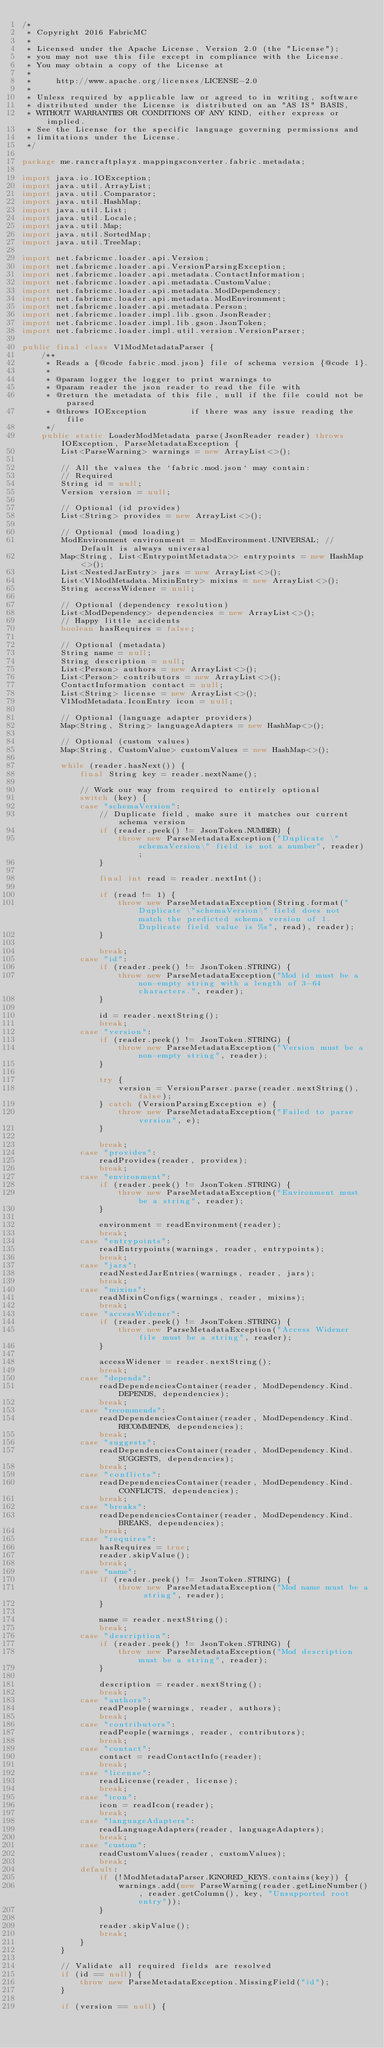Convert code to text. <code><loc_0><loc_0><loc_500><loc_500><_Java_>/*
 * Copyright 2016 FabricMC
 *
 * Licensed under the Apache License, Version 2.0 (the "License");
 * you may not use this file except in compliance with the License.
 * You may obtain a copy of the License at
 *
 *     http://www.apache.org/licenses/LICENSE-2.0
 *
 * Unless required by applicable law or agreed to in writing, software
 * distributed under the License is distributed on an "AS IS" BASIS,
 * WITHOUT WARRANTIES OR CONDITIONS OF ANY KIND, either express or implied.
 * See the License for the specific language governing permissions and
 * limitations under the License.
 */

package me.rancraftplayz.mappingsconverter.fabric.metadata;

import java.io.IOException;
import java.util.ArrayList;
import java.util.Comparator;
import java.util.HashMap;
import java.util.List;
import java.util.Locale;
import java.util.Map;
import java.util.SortedMap;
import java.util.TreeMap;

import net.fabricmc.loader.api.Version;
import net.fabricmc.loader.api.VersionParsingException;
import net.fabricmc.loader.api.metadata.ContactInformation;
import net.fabricmc.loader.api.metadata.CustomValue;
import net.fabricmc.loader.api.metadata.ModDependency;
import net.fabricmc.loader.api.metadata.ModEnvironment;
import net.fabricmc.loader.api.metadata.Person;
import net.fabricmc.loader.impl.lib.gson.JsonReader;
import net.fabricmc.loader.impl.lib.gson.JsonToken;
import net.fabricmc.loader.impl.util.version.VersionParser;

public final class V1ModMetadataParser {
	/**
	 * Reads a {@code fabric.mod.json} file of schema version {@code 1}.
	 *
	 * @param logger the logger to print warnings to
	 * @param reader the json reader to read the file with
	 * @return the metadata of this file, null if the file could not be parsed
	 * @throws IOException         if there was any issue reading the file
	 */
	public static LoaderModMetadata parse(JsonReader reader) throws IOException, ParseMetadataException {
		List<ParseWarning> warnings = new ArrayList<>();

		// All the values the `fabric.mod.json` may contain:
		// Required
		String id = null;
		Version version = null;

		// Optional (id provides)
		List<String> provides = new ArrayList<>();

		// Optional (mod loading)
		ModEnvironment environment = ModEnvironment.UNIVERSAL; // Default is always universal
		Map<String, List<EntrypointMetadata>> entrypoints = new HashMap<>();
		List<NestedJarEntry> jars = new ArrayList<>();
		List<V1ModMetadata.MixinEntry> mixins = new ArrayList<>();
		String accessWidener = null;

		// Optional (dependency resolution)
		List<ModDependency> dependencies = new ArrayList<>();
		// Happy little accidents
		boolean hasRequires = false;

		// Optional (metadata)
		String name = null;
		String description = null;
		List<Person> authors = new ArrayList<>();
		List<Person> contributors = new ArrayList<>();
		ContactInformation contact = null;
		List<String> license = new ArrayList<>();
		V1ModMetadata.IconEntry icon = null;

		// Optional (language adapter providers)
		Map<String, String> languageAdapters = new HashMap<>();

		// Optional (custom values)
		Map<String, CustomValue> customValues = new HashMap<>();

		while (reader.hasNext()) {
			final String key = reader.nextName();

			// Work our way from required to entirely optional
			switch (key) {
			case "schemaVersion":
				// Duplicate field, make sure it matches our current schema version
				if (reader.peek() != JsonToken.NUMBER) {
					throw new ParseMetadataException("Duplicate \"schemaVersion\" field is not a number", reader);
				}

				final int read = reader.nextInt();

				if (read != 1) {
					throw new ParseMetadataException(String.format("Duplicate \"schemaVersion\" field does not match the predicted schema version of 1. Duplicate field value is %s", read), reader);
				}

				break;
			case "id":
				if (reader.peek() != JsonToken.STRING) {
					throw new ParseMetadataException("Mod id must be a non-empty string with a length of 3-64 characters.", reader);
				}

				id = reader.nextString();
				break;
			case "version":
				if (reader.peek() != JsonToken.STRING) {
					throw new ParseMetadataException("Version must be a non-empty string", reader);
				}

				try {
					version = VersionParser.parse(reader.nextString(), false);
				} catch (VersionParsingException e) {
					throw new ParseMetadataException("Failed to parse version", e);
				}

				break;
			case "provides":
				readProvides(reader, provides);
				break;
			case "environment":
				if (reader.peek() != JsonToken.STRING) {
					throw new ParseMetadataException("Environment must be a string", reader);
				}

				environment = readEnvironment(reader);
				break;
			case "entrypoints":
				readEntrypoints(warnings, reader, entrypoints);
				break;
			case "jars":
				readNestedJarEntries(warnings, reader, jars);
				break;
			case "mixins":
				readMixinConfigs(warnings, reader, mixins);
				break;
			case "accessWidener":
				if (reader.peek() != JsonToken.STRING) {
					throw new ParseMetadataException("Access Widener file must be a string", reader);
				}

				accessWidener = reader.nextString();
				break;
			case "depends":
				readDependenciesContainer(reader, ModDependency.Kind.DEPENDS, dependencies);
				break;
			case "recommends":
				readDependenciesContainer(reader, ModDependency.Kind.RECOMMENDS, dependencies);
				break;
			case "suggests":
				readDependenciesContainer(reader, ModDependency.Kind.SUGGESTS, dependencies);
				break;
			case "conflicts":
				readDependenciesContainer(reader, ModDependency.Kind.CONFLICTS, dependencies);
				break;
			case "breaks":
				readDependenciesContainer(reader, ModDependency.Kind.BREAKS, dependencies);
				break;
			case "requires":
				hasRequires = true;
				reader.skipValue();
				break;
			case "name":
				if (reader.peek() != JsonToken.STRING) {
					throw new ParseMetadataException("Mod name must be a string", reader);
				}

				name = reader.nextString();
				break;
			case "description":
				if (reader.peek() != JsonToken.STRING) {
					throw new ParseMetadataException("Mod description must be a string", reader);
				}

				description = reader.nextString();
				break;
			case "authors":
				readPeople(warnings, reader, authors);
				break;
			case "contributors":
				readPeople(warnings, reader, contributors);
				break;
			case "contact":
				contact = readContactInfo(reader);
				break;
			case "license":
				readLicense(reader, license);
				break;
			case "icon":
				icon = readIcon(reader);
				break;
			case "languageAdapters":
				readLanguageAdapters(reader, languageAdapters);
				break;
			case "custom":
				readCustomValues(reader, customValues);
				break;
			default:
				if (!ModMetadataParser.IGNORED_KEYS.contains(key)) {
					warnings.add(new ParseWarning(reader.getLineNumber(), reader.getColumn(), key, "Unsupported root entry"));
				}

				reader.skipValue();
				break;
			}
		}

		// Validate all required fields are resolved
		if (id == null) {
			throw new ParseMetadataException.MissingField("id");
		}

		if (version == null) {</code> 